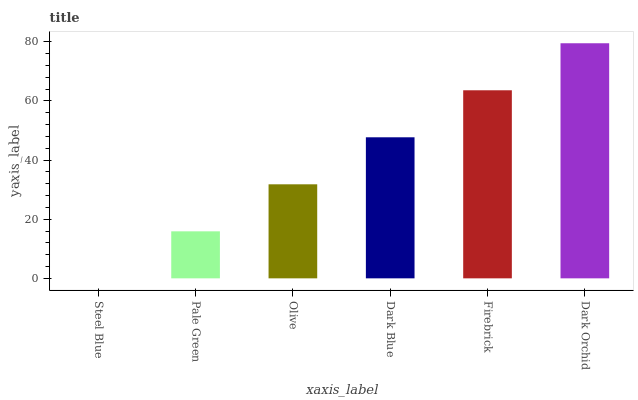Is Steel Blue the minimum?
Answer yes or no. Yes. Is Dark Orchid the maximum?
Answer yes or no. Yes. Is Pale Green the minimum?
Answer yes or no. No. Is Pale Green the maximum?
Answer yes or no. No. Is Pale Green greater than Steel Blue?
Answer yes or no. Yes. Is Steel Blue less than Pale Green?
Answer yes or no. Yes. Is Steel Blue greater than Pale Green?
Answer yes or no. No. Is Pale Green less than Steel Blue?
Answer yes or no. No. Is Dark Blue the high median?
Answer yes or no. Yes. Is Olive the low median?
Answer yes or no. Yes. Is Firebrick the high median?
Answer yes or no. No. Is Firebrick the low median?
Answer yes or no. No. 